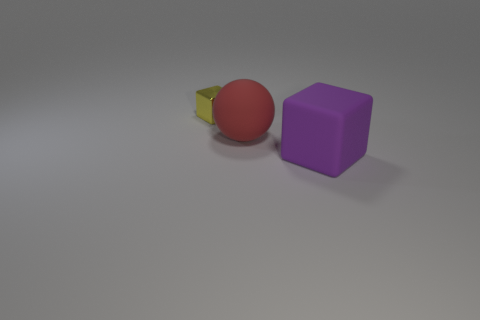Add 3 matte blocks. How many objects exist? 6 Subtract all cubes. How many objects are left? 1 Add 1 brown cylinders. How many brown cylinders exist? 1 Subtract 0 blue balls. How many objects are left? 3 Subtract all purple cubes. Subtract all large objects. How many objects are left? 0 Add 3 yellow cubes. How many yellow cubes are left? 4 